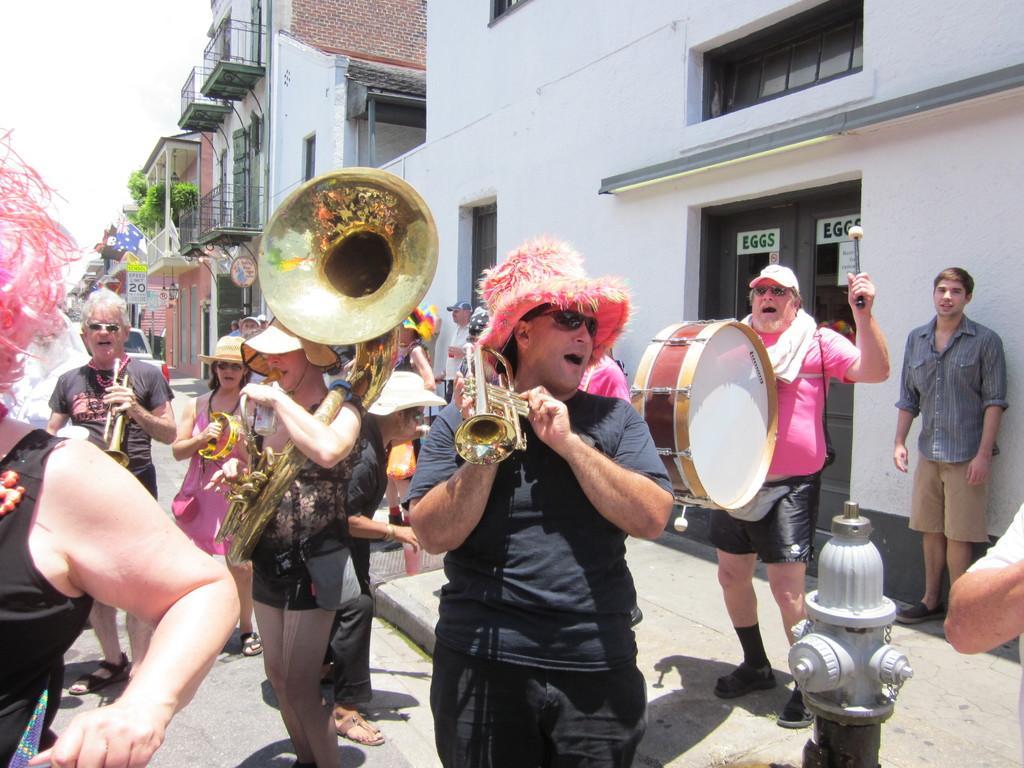In one or two sentences, can you explain what this image depicts? In this image I can see group of people holding few musical instruments. In front the person is wearing black color dress and I can also see the pole in white color, background I can see few buildings in white and brown color, plants in green color and the sky is in white color. 